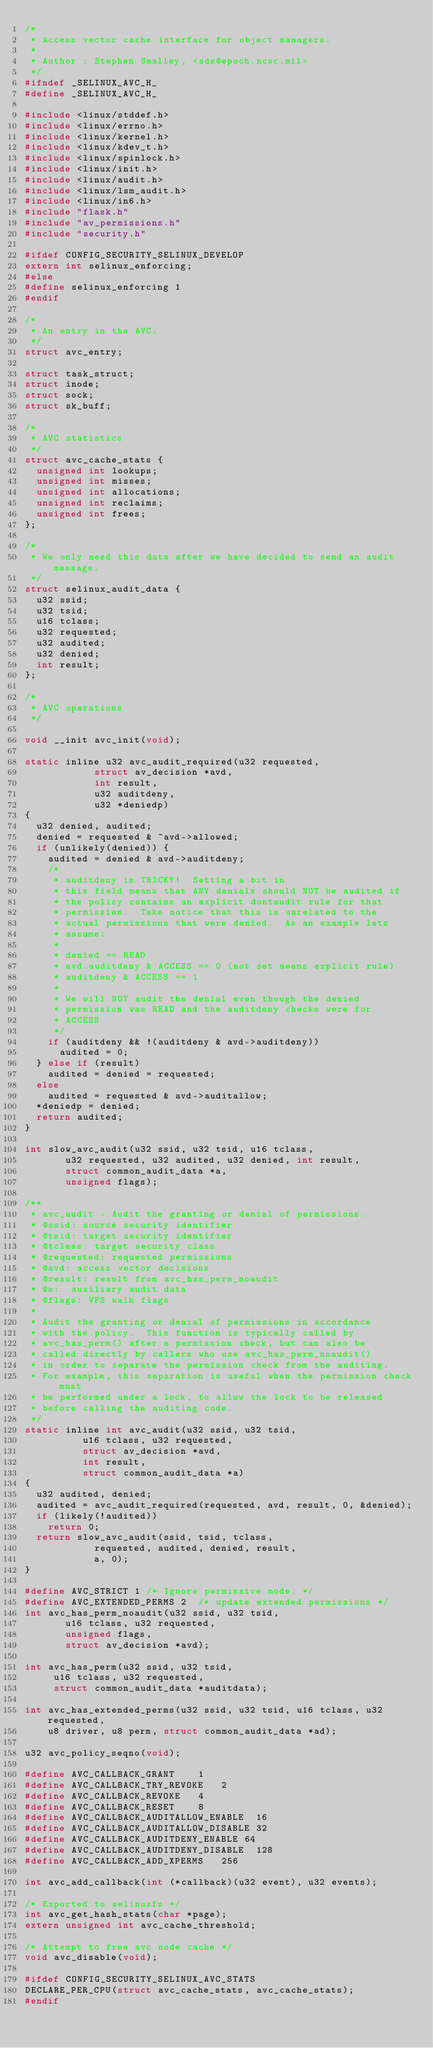Convert code to text. <code><loc_0><loc_0><loc_500><loc_500><_C_>/*
 * Access vector cache interface for object managers.
 *
 * Author : Stephen Smalley, <sds@epoch.ncsc.mil>
 */
#ifndef _SELINUX_AVC_H_
#define _SELINUX_AVC_H_

#include <linux/stddef.h>
#include <linux/errno.h>
#include <linux/kernel.h>
#include <linux/kdev_t.h>
#include <linux/spinlock.h>
#include <linux/init.h>
#include <linux/audit.h>
#include <linux/lsm_audit.h>
#include <linux/in6.h>
#include "flask.h"
#include "av_permissions.h"
#include "security.h"

#ifdef CONFIG_SECURITY_SELINUX_DEVELOP
extern int selinux_enforcing;
#else
#define selinux_enforcing 1
#endif

/*
 * An entry in the AVC.
 */
struct avc_entry;

struct task_struct;
struct inode;
struct sock;
struct sk_buff;

/*
 * AVC statistics
 */
struct avc_cache_stats {
	unsigned int lookups;
	unsigned int misses;
	unsigned int allocations;
	unsigned int reclaims;
	unsigned int frees;
};

/*
 * We only need this data after we have decided to send an audit message.
 */
struct selinux_audit_data {
	u32 ssid;
	u32 tsid;
	u16 tclass;
	u32 requested;
	u32 audited;
	u32 denied;
	int result;
};

/*
 * AVC operations
 */

void __init avc_init(void);

static inline u32 avc_audit_required(u32 requested,
			      struct av_decision *avd,
			      int result,
			      u32 auditdeny,
			      u32 *deniedp)
{
	u32 denied, audited;
	denied = requested & ~avd->allowed;
	if (unlikely(denied)) {
		audited = denied & avd->auditdeny;
		/*
		 * auditdeny is TRICKY!  Setting a bit in
		 * this field means that ANY denials should NOT be audited if
		 * the policy contains an explicit dontaudit rule for that
		 * permission.  Take notice that this is unrelated to the
		 * actual permissions that were denied.  As an example lets
		 * assume:
		 *
		 * denied == READ
		 * avd.auditdeny & ACCESS == 0 (not set means explicit rule)
		 * auditdeny & ACCESS == 1
		 *
		 * We will NOT audit the denial even though the denied
		 * permission was READ and the auditdeny checks were for
		 * ACCESS
		 */
		if (auditdeny && !(auditdeny & avd->auditdeny))
			audited = 0;
	} else if (result)
		audited = denied = requested;
	else
		audited = requested & avd->auditallow;
	*deniedp = denied;
	return audited;
}

int slow_avc_audit(u32 ssid, u32 tsid, u16 tclass,
		   u32 requested, u32 audited, u32 denied, int result,
		   struct common_audit_data *a,
		   unsigned flags);

/**
 * avc_audit - Audit the granting or denial of permissions.
 * @ssid: source security identifier
 * @tsid: target security identifier
 * @tclass: target security class
 * @requested: requested permissions
 * @avd: access vector decisions
 * @result: result from avc_has_perm_noaudit
 * @a:  auxiliary audit data
 * @flags: VFS walk flags
 *
 * Audit the granting or denial of permissions in accordance
 * with the policy.  This function is typically called by
 * avc_has_perm() after a permission check, but can also be
 * called directly by callers who use avc_has_perm_noaudit()
 * in order to separate the permission check from the auditing.
 * For example, this separation is useful when the permission check must
 * be performed under a lock, to allow the lock to be released
 * before calling the auditing code.
 */
static inline int avc_audit(u32 ssid, u32 tsid,
			    u16 tclass, u32 requested,
			    struct av_decision *avd,
			    int result,
			    struct common_audit_data *a)
{
	u32 audited, denied;
	audited = avc_audit_required(requested, avd, result, 0, &denied);
	if (likely(!audited))
		return 0;
	return slow_avc_audit(ssid, tsid, tclass,
			      requested, audited, denied, result,
			      a, 0);
}

#define AVC_STRICT 1 /* Ignore permissive mode. */
#define AVC_EXTENDED_PERMS 2	/* update extended permissions */
int avc_has_perm_noaudit(u32 ssid, u32 tsid,
			 u16 tclass, u32 requested,
			 unsigned flags,
			 struct av_decision *avd);

int avc_has_perm(u32 ssid, u32 tsid,
		 u16 tclass, u32 requested,
		 struct common_audit_data *auditdata);

int avc_has_extended_perms(u32 ssid, u32 tsid, u16 tclass, u32 requested,
		u8 driver, u8 perm, struct common_audit_data *ad);

u32 avc_policy_seqno(void);

#define AVC_CALLBACK_GRANT		1
#define AVC_CALLBACK_TRY_REVOKE		2
#define AVC_CALLBACK_REVOKE		4
#define AVC_CALLBACK_RESET		8
#define AVC_CALLBACK_AUDITALLOW_ENABLE	16
#define AVC_CALLBACK_AUDITALLOW_DISABLE	32
#define AVC_CALLBACK_AUDITDENY_ENABLE	64
#define AVC_CALLBACK_AUDITDENY_DISABLE	128
#define AVC_CALLBACK_ADD_XPERMS		256

int avc_add_callback(int (*callback)(u32 event), u32 events);

/* Exported to selinuxfs */
int avc_get_hash_stats(char *page);
extern unsigned int avc_cache_threshold;

/* Attempt to free avc node cache */
void avc_disable(void);

#ifdef CONFIG_SECURITY_SELINUX_AVC_STATS
DECLARE_PER_CPU(struct avc_cache_stats, avc_cache_stats);
#endif
</code> 